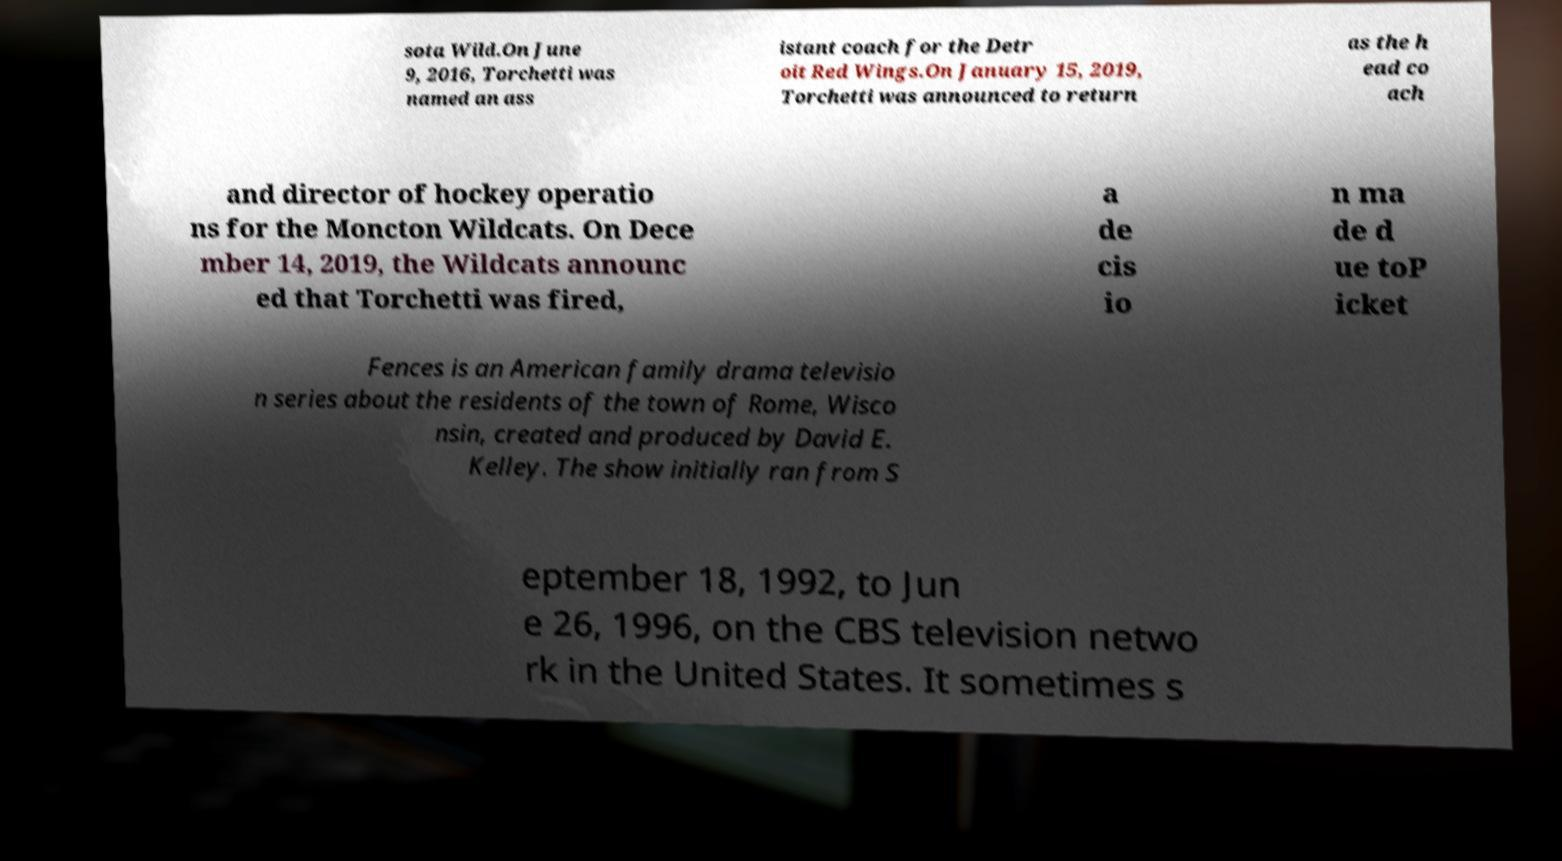There's text embedded in this image that I need extracted. Can you transcribe it verbatim? sota Wild.On June 9, 2016, Torchetti was named an ass istant coach for the Detr oit Red Wings.On January 15, 2019, Torchetti was announced to return as the h ead co ach and director of hockey operatio ns for the Moncton Wildcats. On Dece mber 14, 2019, the Wildcats announc ed that Torchetti was fired, a de cis io n ma de d ue toP icket Fences is an American family drama televisio n series about the residents of the town of Rome, Wisco nsin, created and produced by David E. Kelley. The show initially ran from S eptember 18, 1992, to Jun e 26, 1996, on the CBS television netwo rk in the United States. It sometimes s 